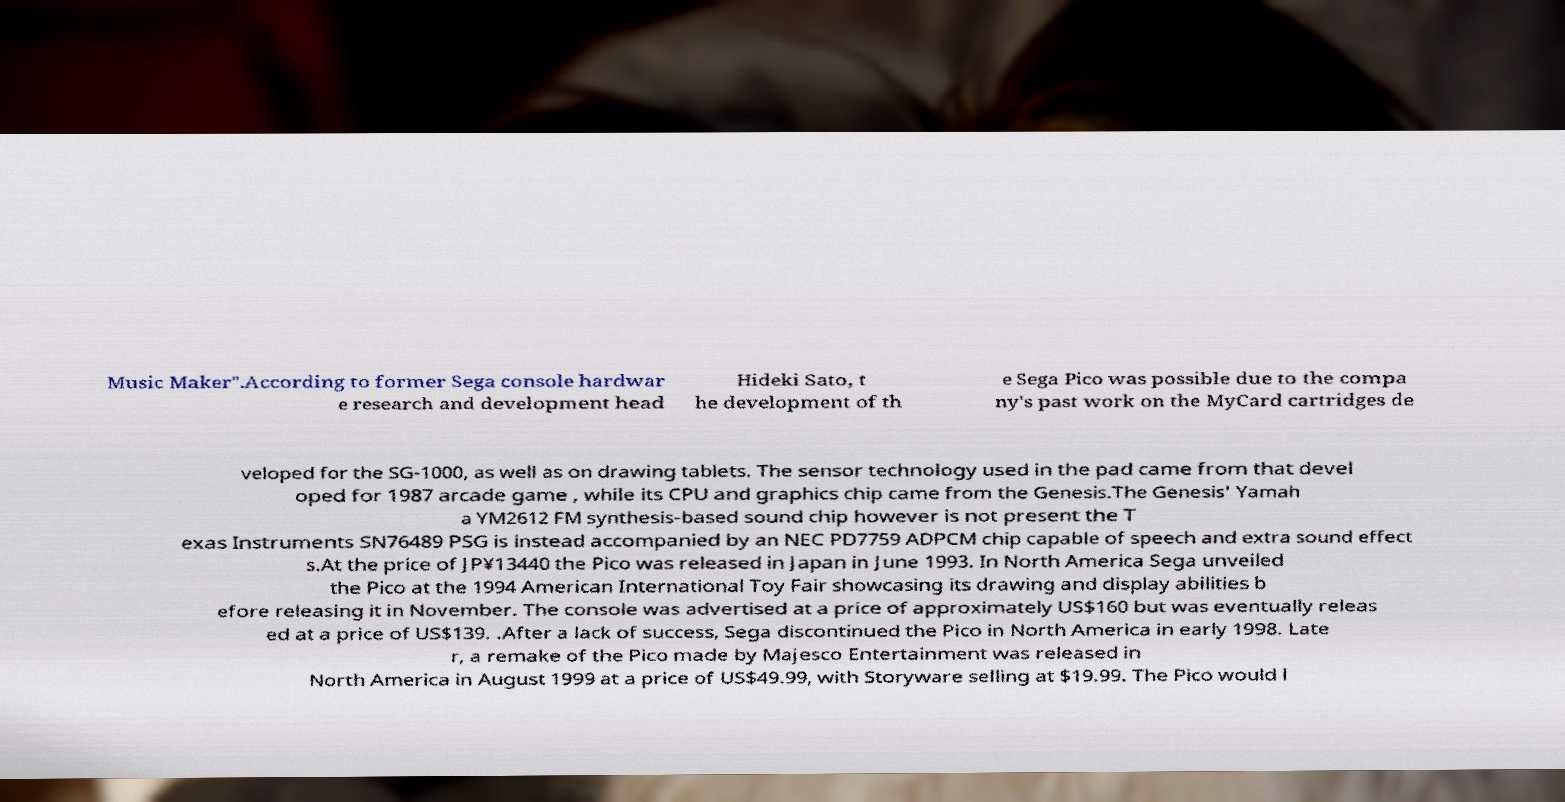Can you read and provide the text displayed in the image?This photo seems to have some interesting text. Can you extract and type it out for me? Music Maker".According to former Sega console hardwar e research and development head Hideki Sato, t he development of th e Sega Pico was possible due to the compa ny's past work on the MyCard cartridges de veloped for the SG-1000, as well as on drawing tablets. The sensor technology used in the pad came from that devel oped for 1987 arcade game , while its CPU and graphics chip came from the Genesis.The Genesis' Yamah a YM2612 FM synthesis-based sound chip however is not present the T exas Instruments SN76489 PSG is instead accompanied by an NEC PD7759 ADPCM chip capable of speech and extra sound effect s.At the price of JP¥13440 the Pico was released in Japan in June 1993. In North America Sega unveiled the Pico at the 1994 American International Toy Fair showcasing its drawing and display abilities b efore releasing it in November. The console was advertised at a price of approximately US$160 but was eventually releas ed at a price of US$139. .After a lack of success, Sega discontinued the Pico in North America in early 1998. Late r, a remake of the Pico made by Majesco Entertainment was released in North America in August 1999 at a price of US$49.99, with Storyware selling at $19.99. The Pico would l 